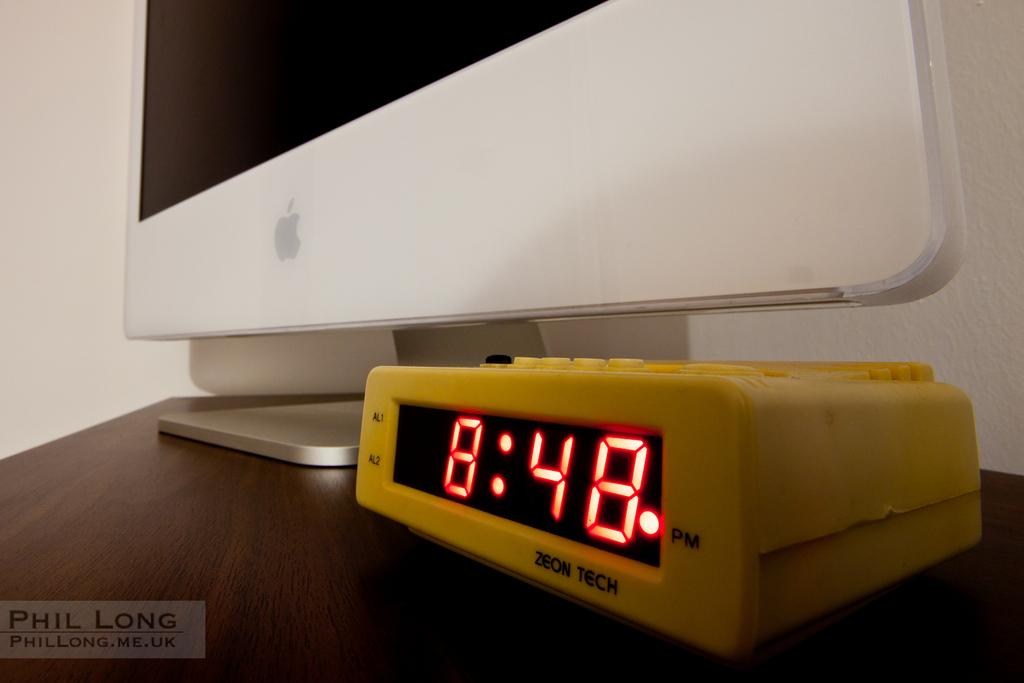<image>
Give a short and clear explanation of the subsequent image. A bright yellow alarm clock reading 8:48 by Zeon Tech. 